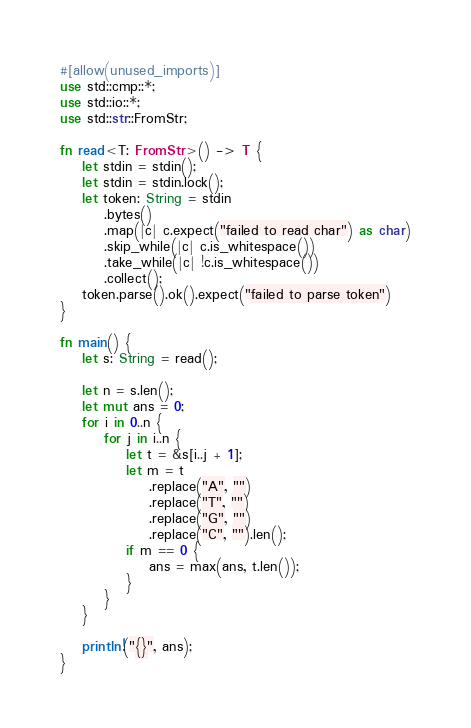Convert code to text. <code><loc_0><loc_0><loc_500><loc_500><_Rust_>#[allow(unused_imports)]
use std::cmp::*;
use std::io::*;
use std::str::FromStr;

fn read<T: FromStr>() -> T {
    let stdin = stdin();
    let stdin = stdin.lock();
    let token: String = stdin
        .bytes()
        .map(|c| c.expect("failed to read char") as char)
        .skip_while(|c| c.is_whitespace())
        .take_while(|c| !c.is_whitespace())
        .collect();
    token.parse().ok().expect("failed to parse token")
}

fn main() {
    let s: String = read();

    let n = s.len();
    let mut ans = 0;
    for i in 0..n {
        for j in i..n {
            let t = &s[i..j + 1];
            let m = t
                .replace("A", "")
                .replace("T", "")
                .replace("G", "")
                .replace("C", "").len();
            if m == 0 {
                ans = max(ans, t.len());
            }
        }
    }

    println!("{}", ans);
}</code> 